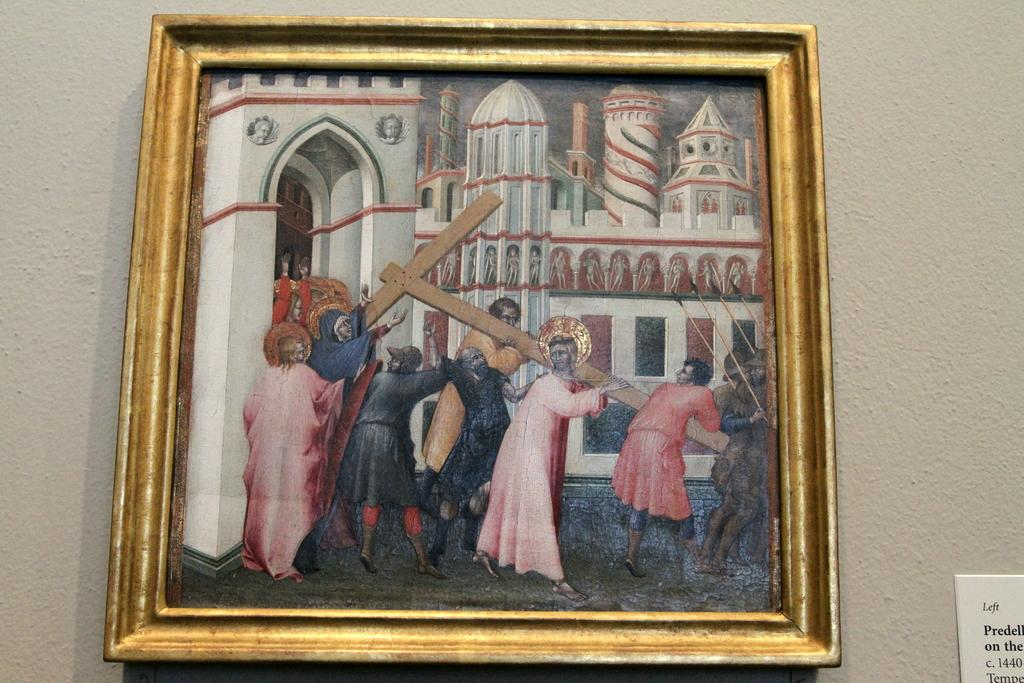What is the main subject of the image? The main subject of the image is a photograph of a painting. Where is the photograph located in the image? The photograph is hanged on a wall. What color of ink is used to write the title of the painting in the image? There is no title or writing visible in the image, so it is not possible to determine the color of ink used. 